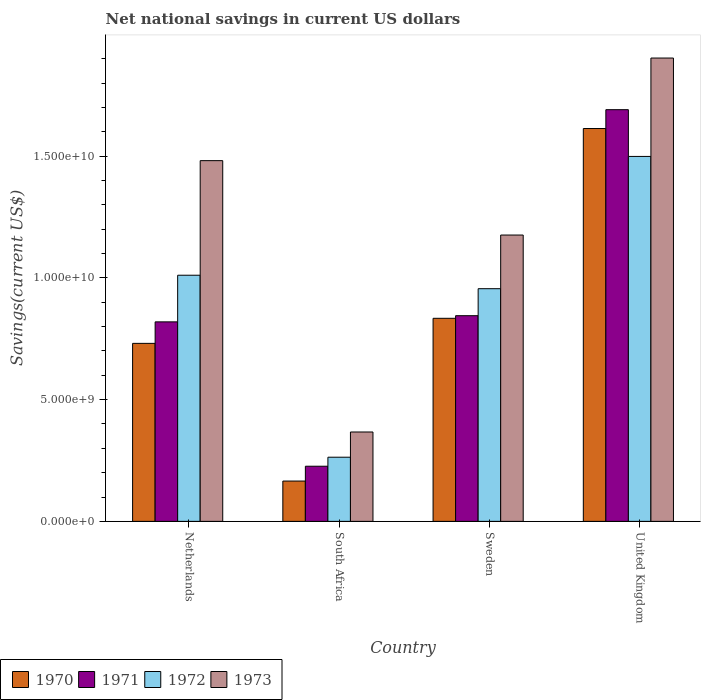Are the number of bars per tick equal to the number of legend labels?
Offer a very short reply. Yes. Are the number of bars on each tick of the X-axis equal?
Your answer should be very brief. Yes. How many bars are there on the 2nd tick from the right?
Your answer should be very brief. 4. What is the label of the 1st group of bars from the left?
Ensure brevity in your answer.  Netherlands. In how many cases, is the number of bars for a given country not equal to the number of legend labels?
Your answer should be very brief. 0. What is the net national savings in 1970 in United Kingdom?
Your answer should be compact. 1.61e+1. Across all countries, what is the maximum net national savings in 1973?
Your answer should be compact. 1.90e+1. Across all countries, what is the minimum net national savings in 1971?
Your response must be concise. 2.27e+09. In which country was the net national savings in 1971 maximum?
Keep it short and to the point. United Kingdom. In which country was the net national savings in 1970 minimum?
Ensure brevity in your answer.  South Africa. What is the total net national savings in 1971 in the graph?
Keep it short and to the point. 3.58e+1. What is the difference between the net national savings in 1970 in Netherlands and that in United Kingdom?
Ensure brevity in your answer.  -8.83e+09. What is the difference between the net national savings in 1973 in Netherlands and the net national savings in 1970 in United Kingdom?
Your answer should be very brief. -1.32e+09. What is the average net national savings in 1971 per country?
Your response must be concise. 8.96e+09. What is the difference between the net national savings of/in 1970 and net national savings of/in 1972 in United Kingdom?
Offer a terse response. 1.15e+09. What is the ratio of the net national savings in 1973 in Netherlands to that in Sweden?
Your response must be concise. 1.26. Is the net national savings in 1972 in Netherlands less than that in South Africa?
Your answer should be compact. No. Is the difference between the net national savings in 1970 in Netherlands and South Africa greater than the difference between the net national savings in 1972 in Netherlands and South Africa?
Your response must be concise. No. What is the difference between the highest and the second highest net national savings in 1972?
Make the answer very short. 5.54e+08. What is the difference between the highest and the lowest net national savings in 1970?
Provide a succinct answer. 1.45e+1. Is the sum of the net national savings in 1970 in Netherlands and Sweden greater than the maximum net national savings in 1973 across all countries?
Give a very brief answer. No. Is it the case that in every country, the sum of the net national savings in 1973 and net national savings in 1971 is greater than the sum of net national savings in 1972 and net national savings in 1970?
Offer a very short reply. No. What does the 1st bar from the left in Netherlands represents?
Make the answer very short. 1970. What does the 4th bar from the right in United Kingdom represents?
Your answer should be compact. 1970. How many bars are there?
Make the answer very short. 16. Are all the bars in the graph horizontal?
Your response must be concise. No. How many countries are there in the graph?
Offer a very short reply. 4. Are the values on the major ticks of Y-axis written in scientific E-notation?
Provide a succinct answer. Yes. How are the legend labels stacked?
Give a very brief answer. Horizontal. What is the title of the graph?
Keep it short and to the point. Net national savings in current US dollars. What is the label or title of the Y-axis?
Your response must be concise. Savings(current US$). What is the Savings(current US$) of 1970 in Netherlands?
Your answer should be very brief. 7.31e+09. What is the Savings(current US$) of 1971 in Netherlands?
Give a very brief answer. 8.20e+09. What is the Savings(current US$) in 1972 in Netherlands?
Make the answer very short. 1.01e+1. What is the Savings(current US$) of 1973 in Netherlands?
Offer a very short reply. 1.48e+1. What is the Savings(current US$) in 1970 in South Africa?
Your response must be concise. 1.66e+09. What is the Savings(current US$) of 1971 in South Africa?
Ensure brevity in your answer.  2.27e+09. What is the Savings(current US$) of 1972 in South Africa?
Offer a very short reply. 2.64e+09. What is the Savings(current US$) of 1973 in South Africa?
Your response must be concise. 3.67e+09. What is the Savings(current US$) of 1970 in Sweden?
Give a very brief answer. 8.34e+09. What is the Savings(current US$) of 1971 in Sweden?
Make the answer very short. 8.45e+09. What is the Savings(current US$) in 1972 in Sweden?
Keep it short and to the point. 9.56e+09. What is the Savings(current US$) in 1973 in Sweden?
Offer a terse response. 1.18e+1. What is the Savings(current US$) of 1970 in United Kingdom?
Provide a short and direct response. 1.61e+1. What is the Savings(current US$) of 1971 in United Kingdom?
Your answer should be very brief. 1.69e+1. What is the Savings(current US$) in 1972 in United Kingdom?
Keep it short and to the point. 1.50e+1. What is the Savings(current US$) in 1973 in United Kingdom?
Your answer should be compact. 1.90e+1. Across all countries, what is the maximum Savings(current US$) of 1970?
Make the answer very short. 1.61e+1. Across all countries, what is the maximum Savings(current US$) in 1971?
Ensure brevity in your answer.  1.69e+1. Across all countries, what is the maximum Savings(current US$) in 1972?
Your response must be concise. 1.50e+1. Across all countries, what is the maximum Savings(current US$) in 1973?
Keep it short and to the point. 1.90e+1. Across all countries, what is the minimum Savings(current US$) in 1970?
Keep it short and to the point. 1.66e+09. Across all countries, what is the minimum Savings(current US$) in 1971?
Provide a short and direct response. 2.27e+09. Across all countries, what is the minimum Savings(current US$) of 1972?
Keep it short and to the point. 2.64e+09. Across all countries, what is the minimum Savings(current US$) of 1973?
Make the answer very short. 3.67e+09. What is the total Savings(current US$) in 1970 in the graph?
Give a very brief answer. 3.34e+1. What is the total Savings(current US$) in 1971 in the graph?
Offer a terse response. 3.58e+1. What is the total Savings(current US$) in 1972 in the graph?
Provide a succinct answer. 3.73e+1. What is the total Savings(current US$) in 1973 in the graph?
Your answer should be compact. 4.93e+1. What is the difference between the Savings(current US$) of 1970 in Netherlands and that in South Africa?
Make the answer very short. 5.66e+09. What is the difference between the Savings(current US$) of 1971 in Netherlands and that in South Africa?
Make the answer very short. 5.93e+09. What is the difference between the Savings(current US$) in 1972 in Netherlands and that in South Africa?
Make the answer very short. 7.48e+09. What is the difference between the Savings(current US$) in 1973 in Netherlands and that in South Africa?
Provide a short and direct response. 1.11e+1. What is the difference between the Savings(current US$) of 1970 in Netherlands and that in Sweden?
Your answer should be very brief. -1.03e+09. What is the difference between the Savings(current US$) of 1971 in Netherlands and that in Sweden?
Provide a succinct answer. -2.53e+08. What is the difference between the Savings(current US$) in 1972 in Netherlands and that in Sweden?
Your answer should be very brief. 5.54e+08. What is the difference between the Savings(current US$) in 1973 in Netherlands and that in Sweden?
Your answer should be very brief. 3.06e+09. What is the difference between the Savings(current US$) in 1970 in Netherlands and that in United Kingdom?
Provide a succinct answer. -8.83e+09. What is the difference between the Savings(current US$) in 1971 in Netherlands and that in United Kingdom?
Ensure brevity in your answer.  -8.72e+09. What is the difference between the Savings(current US$) in 1972 in Netherlands and that in United Kingdom?
Provide a short and direct response. -4.88e+09. What is the difference between the Savings(current US$) of 1973 in Netherlands and that in United Kingdom?
Your answer should be compact. -4.22e+09. What is the difference between the Savings(current US$) of 1970 in South Africa and that in Sweden?
Your response must be concise. -6.69e+09. What is the difference between the Savings(current US$) of 1971 in South Africa and that in Sweden?
Offer a terse response. -6.18e+09. What is the difference between the Savings(current US$) of 1972 in South Africa and that in Sweden?
Provide a short and direct response. -6.92e+09. What is the difference between the Savings(current US$) of 1973 in South Africa and that in Sweden?
Your answer should be compact. -8.09e+09. What is the difference between the Savings(current US$) of 1970 in South Africa and that in United Kingdom?
Your answer should be compact. -1.45e+1. What is the difference between the Savings(current US$) in 1971 in South Africa and that in United Kingdom?
Your answer should be compact. -1.46e+1. What is the difference between the Savings(current US$) in 1972 in South Africa and that in United Kingdom?
Give a very brief answer. -1.24e+1. What is the difference between the Savings(current US$) of 1973 in South Africa and that in United Kingdom?
Your answer should be very brief. -1.54e+1. What is the difference between the Savings(current US$) in 1970 in Sweden and that in United Kingdom?
Ensure brevity in your answer.  -7.80e+09. What is the difference between the Savings(current US$) of 1971 in Sweden and that in United Kingdom?
Give a very brief answer. -8.46e+09. What is the difference between the Savings(current US$) in 1972 in Sweden and that in United Kingdom?
Your answer should be compact. -5.43e+09. What is the difference between the Savings(current US$) of 1973 in Sweden and that in United Kingdom?
Your answer should be compact. -7.27e+09. What is the difference between the Savings(current US$) of 1970 in Netherlands and the Savings(current US$) of 1971 in South Africa?
Your answer should be compact. 5.05e+09. What is the difference between the Savings(current US$) in 1970 in Netherlands and the Savings(current US$) in 1972 in South Africa?
Provide a succinct answer. 4.68e+09. What is the difference between the Savings(current US$) of 1970 in Netherlands and the Savings(current US$) of 1973 in South Africa?
Offer a terse response. 3.64e+09. What is the difference between the Savings(current US$) of 1971 in Netherlands and the Savings(current US$) of 1972 in South Africa?
Your answer should be very brief. 5.56e+09. What is the difference between the Savings(current US$) in 1971 in Netherlands and the Savings(current US$) in 1973 in South Africa?
Your answer should be compact. 4.52e+09. What is the difference between the Savings(current US$) in 1972 in Netherlands and the Savings(current US$) in 1973 in South Africa?
Give a very brief answer. 6.44e+09. What is the difference between the Savings(current US$) of 1970 in Netherlands and the Savings(current US$) of 1971 in Sweden?
Your response must be concise. -1.14e+09. What is the difference between the Savings(current US$) of 1970 in Netherlands and the Savings(current US$) of 1972 in Sweden?
Your answer should be compact. -2.25e+09. What is the difference between the Savings(current US$) in 1970 in Netherlands and the Savings(current US$) in 1973 in Sweden?
Your response must be concise. -4.45e+09. What is the difference between the Savings(current US$) in 1971 in Netherlands and the Savings(current US$) in 1972 in Sweden?
Offer a terse response. -1.36e+09. What is the difference between the Savings(current US$) of 1971 in Netherlands and the Savings(current US$) of 1973 in Sweden?
Ensure brevity in your answer.  -3.57e+09. What is the difference between the Savings(current US$) in 1972 in Netherlands and the Savings(current US$) in 1973 in Sweden?
Provide a short and direct response. -1.65e+09. What is the difference between the Savings(current US$) of 1970 in Netherlands and the Savings(current US$) of 1971 in United Kingdom?
Keep it short and to the point. -9.60e+09. What is the difference between the Savings(current US$) in 1970 in Netherlands and the Savings(current US$) in 1972 in United Kingdom?
Make the answer very short. -7.68e+09. What is the difference between the Savings(current US$) in 1970 in Netherlands and the Savings(current US$) in 1973 in United Kingdom?
Offer a terse response. -1.17e+1. What is the difference between the Savings(current US$) in 1971 in Netherlands and the Savings(current US$) in 1972 in United Kingdom?
Give a very brief answer. -6.80e+09. What is the difference between the Savings(current US$) in 1971 in Netherlands and the Savings(current US$) in 1973 in United Kingdom?
Keep it short and to the point. -1.08e+1. What is the difference between the Savings(current US$) in 1972 in Netherlands and the Savings(current US$) in 1973 in United Kingdom?
Keep it short and to the point. -8.92e+09. What is the difference between the Savings(current US$) in 1970 in South Africa and the Savings(current US$) in 1971 in Sweden?
Give a very brief answer. -6.79e+09. What is the difference between the Savings(current US$) of 1970 in South Africa and the Savings(current US$) of 1972 in Sweden?
Give a very brief answer. -7.90e+09. What is the difference between the Savings(current US$) in 1970 in South Africa and the Savings(current US$) in 1973 in Sweden?
Give a very brief answer. -1.01e+1. What is the difference between the Savings(current US$) of 1971 in South Africa and the Savings(current US$) of 1972 in Sweden?
Make the answer very short. -7.29e+09. What is the difference between the Savings(current US$) of 1971 in South Africa and the Savings(current US$) of 1973 in Sweden?
Make the answer very short. -9.50e+09. What is the difference between the Savings(current US$) in 1972 in South Africa and the Savings(current US$) in 1973 in Sweden?
Provide a short and direct response. -9.13e+09. What is the difference between the Savings(current US$) in 1970 in South Africa and the Savings(current US$) in 1971 in United Kingdom?
Your answer should be very brief. -1.53e+1. What is the difference between the Savings(current US$) in 1970 in South Africa and the Savings(current US$) in 1972 in United Kingdom?
Your response must be concise. -1.33e+1. What is the difference between the Savings(current US$) of 1970 in South Africa and the Savings(current US$) of 1973 in United Kingdom?
Make the answer very short. -1.74e+1. What is the difference between the Savings(current US$) in 1971 in South Africa and the Savings(current US$) in 1972 in United Kingdom?
Offer a terse response. -1.27e+1. What is the difference between the Savings(current US$) in 1971 in South Africa and the Savings(current US$) in 1973 in United Kingdom?
Offer a terse response. -1.68e+1. What is the difference between the Savings(current US$) in 1972 in South Africa and the Savings(current US$) in 1973 in United Kingdom?
Make the answer very short. -1.64e+1. What is the difference between the Savings(current US$) of 1970 in Sweden and the Savings(current US$) of 1971 in United Kingdom?
Offer a terse response. -8.57e+09. What is the difference between the Savings(current US$) in 1970 in Sweden and the Savings(current US$) in 1972 in United Kingdom?
Your response must be concise. -6.65e+09. What is the difference between the Savings(current US$) of 1970 in Sweden and the Savings(current US$) of 1973 in United Kingdom?
Offer a very short reply. -1.07e+1. What is the difference between the Savings(current US$) in 1971 in Sweden and the Savings(current US$) in 1972 in United Kingdom?
Provide a short and direct response. -6.54e+09. What is the difference between the Savings(current US$) in 1971 in Sweden and the Savings(current US$) in 1973 in United Kingdom?
Provide a succinct answer. -1.06e+1. What is the difference between the Savings(current US$) of 1972 in Sweden and the Savings(current US$) of 1973 in United Kingdom?
Ensure brevity in your answer.  -9.48e+09. What is the average Savings(current US$) in 1970 per country?
Ensure brevity in your answer.  8.36e+09. What is the average Savings(current US$) of 1971 per country?
Offer a terse response. 8.96e+09. What is the average Savings(current US$) of 1972 per country?
Your answer should be compact. 9.32e+09. What is the average Savings(current US$) of 1973 per country?
Your response must be concise. 1.23e+1. What is the difference between the Savings(current US$) in 1970 and Savings(current US$) in 1971 in Netherlands?
Provide a succinct answer. -8.83e+08. What is the difference between the Savings(current US$) of 1970 and Savings(current US$) of 1972 in Netherlands?
Provide a succinct answer. -2.80e+09. What is the difference between the Savings(current US$) of 1970 and Savings(current US$) of 1973 in Netherlands?
Make the answer very short. -7.51e+09. What is the difference between the Savings(current US$) in 1971 and Savings(current US$) in 1972 in Netherlands?
Keep it short and to the point. -1.92e+09. What is the difference between the Savings(current US$) in 1971 and Savings(current US$) in 1973 in Netherlands?
Ensure brevity in your answer.  -6.62e+09. What is the difference between the Savings(current US$) in 1972 and Savings(current US$) in 1973 in Netherlands?
Your response must be concise. -4.71e+09. What is the difference between the Savings(current US$) in 1970 and Savings(current US$) in 1971 in South Africa?
Offer a terse response. -6.09e+08. What is the difference between the Savings(current US$) of 1970 and Savings(current US$) of 1972 in South Africa?
Your answer should be compact. -9.79e+08. What is the difference between the Savings(current US$) in 1970 and Savings(current US$) in 1973 in South Africa?
Offer a terse response. -2.02e+09. What is the difference between the Savings(current US$) of 1971 and Savings(current US$) of 1972 in South Africa?
Your answer should be compact. -3.70e+08. What is the difference between the Savings(current US$) of 1971 and Savings(current US$) of 1973 in South Africa?
Your answer should be very brief. -1.41e+09. What is the difference between the Savings(current US$) in 1972 and Savings(current US$) in 1973 in South Africa?
Offer a terse response. -1.04e+09. What is the difference between the Savings(current US$) in 1970 and Savings(current US$) in 1971 in Sweden?
Your answer should be compact. -1.07e+08. What is the difference between the Savings(current US$) in 1970 and Savings(current US$) in 1972 in Sweden?
Your answer should be compact. -1.22e+09. What is the difference between the Savings(current US$) of 1970 and Savings(current US$) of 1973 in Sweden?
Your answer should be compact. -3.42e+09. What is the difference between the Savings(current US$) of 1971 and Savings(current US$) of 1972 in Sweden?
Provide a succinct answer. -1.11e+09. What is the difference between the Savings(current US$) of 1971 and Savings(current US$) of 1973 in Sweden?
Offer a terse response. -3.31e+09. What is the difference between the Savings(current US$) of 1972 and Savings(current US$) of 1973 in Sweden?
Your answer should be compact. -2.20e+09. What is the difference between the Savings(current US$) in 1970 and Savings(current US$) in 1971 in United Kingdom?
Ensure brevity in your answer.  -7.74e+08. What is the difference between the Savings(current US$) in 1970 and Savings(current US$) in 1972 in United Kingdom?
Ensure brevity in your answer.  1.15e+09. What is the difference between the Savings(current US$) in 1970 and Savings(current US$) in 1973 in United Kingdom?
Give a very brief answer. -2.90e+09. What is the difference between the Savings(current US$) in 1971 and Savings(current US$) in 1972 in United Kingdom?
Make the answer very short. 1.92e+09. What is the difference between the Savings(current US$) in 1971 and Savings(current US$) in 1973 in United Kingdom?
Offer a very short reply. -2.12e+09. What is the difference between the Savings(current US$) in 1972 and Savings(current US$) in 1973 in United Kingdom?
Offer a very short reply. -4.04e+09. What is the ratio of the Savings(current US$) of 1970 in Netherlands to that in South Africa?
Give a very brief answer. 4.42. What is the ratio of the Savings(current US$) of 1971 in Netherlands to that in South Africa?
Ensure brevity in your answer.  3.62. What is the ratio of the Savings(current US$) in 1972 in Netherlands to that in South Africa?
Your response must be concise. 3.84. What is the ratio of the Savings(current US$) of 1973 in Netherlands to that in South Africa?
Your answer should be compact. 4.04. What is the ratio of the Savings(current US$) of 1970 in Netherlands to that in Sweden?
Your answer should be very brief. 0.88. What is the ratio of the Savings(current US$) of 1971 in Netherlands to that in Sweden?
Offer a terse response. 0.97. What is the ratio of the Savings(current US$) of 1972 in Netherlands to that in Sweden?
Offer a terse response. 1.06. What is the ratio of the Savings(current US$) in 1973 in Netherlands to that in Sweden?
Ensure brevity in your answer.  1.26. What is the ratio of the Savings(current US$) in 1970 in Netherlands to that in United Kingdom?
Offer a terse response. 0.45. What is the ratio of the Savings(current US$) in 1971 in Netherlands to that in United Kingdom?
Provide a succinct answer. 0.48. What is the ratio of the Savings(current US$) in 1972 in Netherlands to that in United Kingdom?
Give a very brief answer. 0.67. What is the ratio of the Savings(current US$) of 1973 in Netherlands to that in United Kingdom?
Keep it short and to the point. 0.78. What is the ratio of the Savings(current US$) in 1970 in South Africa to that in Sweden?
Ensure brevity in your answer.  0.2. What is the ratio of the Savings(current US$) of 1971 in South Africa to that in Sweden?
Your response must be concise. 0.27. What is the ratio of the Savings(current US$) in 1972 in South Africa to that in Sweden?
Your answer should be compact. 0.28. What is the ratio of the Savings(current US$) in 1973 in South Africa to that in Sweden?
Your answer should be compact. 0.31. What is the ratio of the Savings(current US$) of 1970 in South Africa to that in United Kingdom?
Offer a very short reply. 0.1. What is the ratio of the Savings(current US$) in 1971 in South Africa to that in United Kingdom?
Keep it short and to the point. 0.13. What is the ratio of the Savings(current US$) in 1972 in South Africa to that in United Kingdom?
Your answer should be compact. 0.18. What is the ratio of the Savings(current US$) of 1973 in South Africa to that in United Kingdom?
Provide a succinct answer. 0.19. What is the ratio of the Savings(current US$) in 1970 in Sweden to that in United Kingdom?
Provide a short and direct response. 0.52. What is the ratio of the Savings(current US$) of 1971 in Sweden to that in United Kingdom?
Your response must be concise. 0.5. What is the ratio of the Savings(current US$) of 1972 in Sweden to that in United Kingdom?
Ensure brevity in your answer.  0.64. What is the ratio of the Savings(current US$) in 1973 in Sweden to that in United Kingdom?
Your response must be concise. 0.62. What is the difference between the highest and the second highest Savings(current US$) of 1970?
Ensure brevity in your answer.  7.80e+09. What is the difference between the highest and the second highest Savings(current US$) in 1971?
Offer a very short reply. 8.46e+09. What is the difference between the highest and the second highest Savings(current US$) of 1972?
Your answer should be compact. 4.88e+09. What is the difference between the highest and the second highest Savings(current US$) in 1973?
Offer a terse response. 4.22e+09. What is the difference between the highest and the lowest Savings(current US$) of 1970?
Keep it short and to the point. 1.45e+1. What is the difference between the highest and the lowest Savings(current US$) in 1971?
Make the answer very short. 1.46e+1. What is the difference between the highest and the lowest Savings(current US$) in 1972?
Offer a very short reply. 1.24e+1. What is the difference between the highest and the lowest Savings(current US$) in 1973?
Keep it short and to the point. 1.54e+1. 